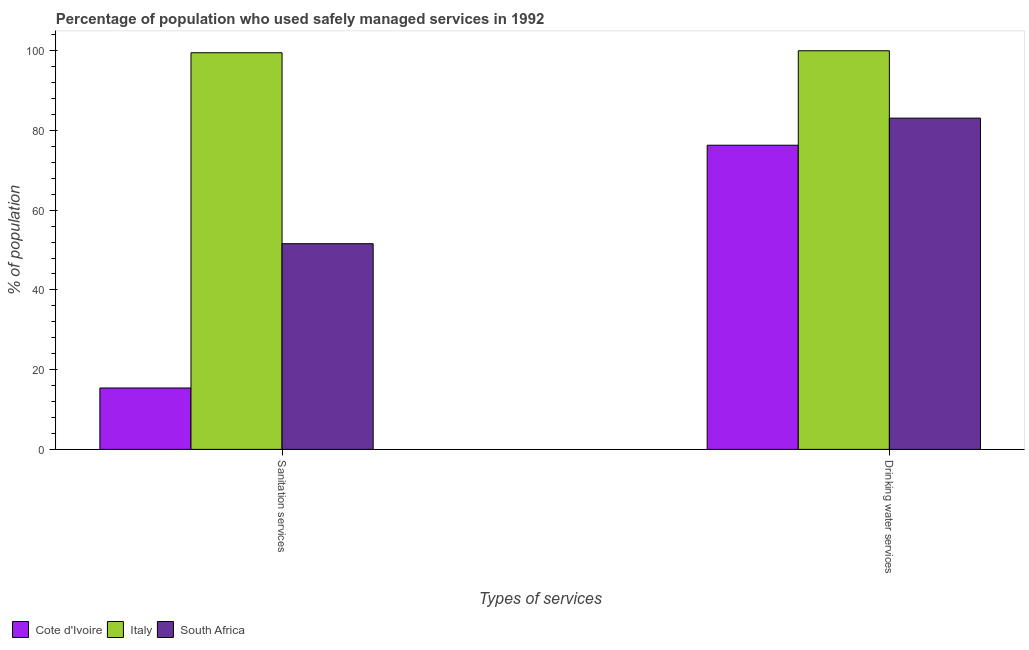How many different coloured bars are there?
Give a very brief answer. 3. How many groups of bars are there?
Provide a short and direct response. 2. What is the label of the 2nd group of bars from the left?
Your answer should be compact. Drinking water services. What is the percentage of population who used sanitation services in Italy?
Ensure brevity in your answer.  99.5. Across all countries, what is the maximum percentage of population who used drinking water services?
Offer a very short reply. 100. Across all countries, what is the minimum percentage of population who used sanitation services?
Your answer should be very brief. 15.4. In which country was the percentage of population who used drinking water services maximum?
Give a very brief answer. Italy. In which country was the percentage of population who used sanitation services minimum?
Keep it short and to the point. Cote d'Ivoire. What is the total percentage of population who used sanitation services in the graph?
Offer a very short reply. 166.5. What is the difference between the percentage of population who used drinking water services in Cote d'Ivoire and that in South Africa?
Your response must be concise. -6.8. What is the difference between the percentage of population who used drinking water services in South Africa and the percentage of population who used sanitation services in Italy?
Keep it short and to the point. -16.4. What is the average percentage of population who used drinking water services per country?
Keep it short and to the point. 86.47. What is the difference between the percentage of population who used drinking water services and percentage of population who used sanitation services in Italy?
Keep it short and to the point. 0.5. In how many countries, is the percentage of population who used sanitation services greater than 68 %?
Provide a succinct answer. 1. What is the ratio of the percentage of population who used drinking water services in South Africa to that in Italy?
Your response must be concise. 0.83. What does the 3rd bar from the right in Sanitation services represents?
Make the answer very short. Cote d'Ivoire. Are all the bars in the graph horizontal?
Offer a very short reply. No. How many countries are there in the graph?
Ensure brevity in your answer.  3. Does the graph contain any zero values?
Provide a succinct answer. No. Where does the legend appear in the graph?
Offer a terse response. Bottom left. How are the legend labels stacked?
Your answer should be compact. Horizontal. What is the title of the graph?
Offer a terse response. Percentage of population who used safely managed services in 1992. Does "Oman" appear as one of the legend labels in the graph?
Your answer should be compact. No. What is the label or title of the X-axis?
Your answer should be very brief. Types of services. What is the label or title of the Y-axis?
Make the answer very short. % of population. What is the % of population in Cote d'Ivoire in Sanitation services?
Offer a terse response. 15.4. What is the % of population of Italy in Sanitation services?
Your response must be concise. 99.5. What is the % of population of South Africa in Sanitation services?
Your answer should be compact. 51.6. What is the % of population of Cote d'Ivoire in Drinking water services?
Provide a short and direct response. 76.3. What is the % of population of South Africa in Drinking water services?
Keep it short and to the point. 83.1. Across all Types of services, what is the maximum % of population of Cote d'Ivoire?
Give a very brief answer. 76.3. Across all Types of services, what is the maximum % of population in Italy?
Keep it short and to the point. 100. Across all Types of services, what is the maximum % of population of South Africa?
Provide a short and direct response. 83.1. Across all Types of services, what is the minimum % of population in Cote d'Ivoire?
Offer a terse response. 15.4. Across all Types of services, what is the minimum % of population in Italy?
Provide a succinct answer. 99.5. Across all Types of services, what is the minimum % of population in South Africa?
Your answer should be very brief. 51.6. What is the total % of population of Cote d'Ivoire in the graph?
Your response must be concise. 91.7. What is the total % of population of Italy in the graph?
Make the answer very short. 199.5. What is the total % of population in South Africa in the graph?
Keep it short and to the point. 134.7. What is the difference between the % of population of Cote d'Ivoire in Sanitation services and that in Drinking water services?
Make the answer very short. -60.9. What is the difference between the % of population in South Africa in Sanitation services and that in Drinking water services?
Offer a very short reply. -31.5. What is the difference between the % of population of Cote d'Ivoire in Sanitation services and the % of population of Italy in Drinking water services?
Your response must be concise. -84.6. What is the difference between the % of population in Cote d'Ivoire in Sanitation services and the % of population in South Africa in Drinking water services?
Make the answer very short. -67.7. What is the difference between the % of population in Italy in Sanitation services and the % of population in South Africa in Drinking water services?
Provide a succinct answer. 16.4. What is the average % of population in Cote d'Ivoire per Types of services?
Give a very brief answer. 45.85. What is the average % of population of Italy per Types of services?
Provide a short and direct response. 99.75. What is the average % of population of South Africa per Types of services?
Keep it short and to the point. 67.35. What is the difference between the % of population of Cote d'Ivoire and % of population of Italy in Sanitation services?
Give a very brief answer. -84.1. What is the difference between the % of population of Cote d'Ivoire and % of population of South Africa in Sanitation services?
Provide a short and direct response. -36.2. What is the difference between the % of population in Italy and % of population in South Africa in Sanitation services?
Your answer should be compact. 47.9. What is the difference between the % of population of Cote d'Ivoire and % of population of Italy in Drinking water services?
Provide a succinct answer. -23.7. What is the difference between the % of population in Cote d'Ivoire and % of population in South Africa in Drinking water services?
Provide a succinct answer. -6.8. What is the ratio of the % of population in Cote d'Ivoire in Sanitation services to that in Drinking water services?
Provide a succinct answer. 0.2. What is the ratio of the % of population in Italy in Sanitation services to that in Drinking water services?
Offer a very short reply. 0.99. What is the ratio of the % of population of South Africa in Sanitation services to that in Drinking water services?
Offer a terse response. 0.62. What is the difference between the highest and the second highest % of population of Cote d'Ivoire?
Make the answer very short. 60.9. What is the difference between the highest and the second highest % of population of South Africa?
Give a very brief answer. 31.5. What is the difference between the highest and the lowest % of population in Cote d'Ivoire?
Offer a very short reply. 60.9. What is the difference between the highest and the lowest % of population of Italy?
Provide a short and direct response. 0.5. What is the difference between the highest and the lowest % of population in South Africa?
Offer a very short reply. 31.5. 